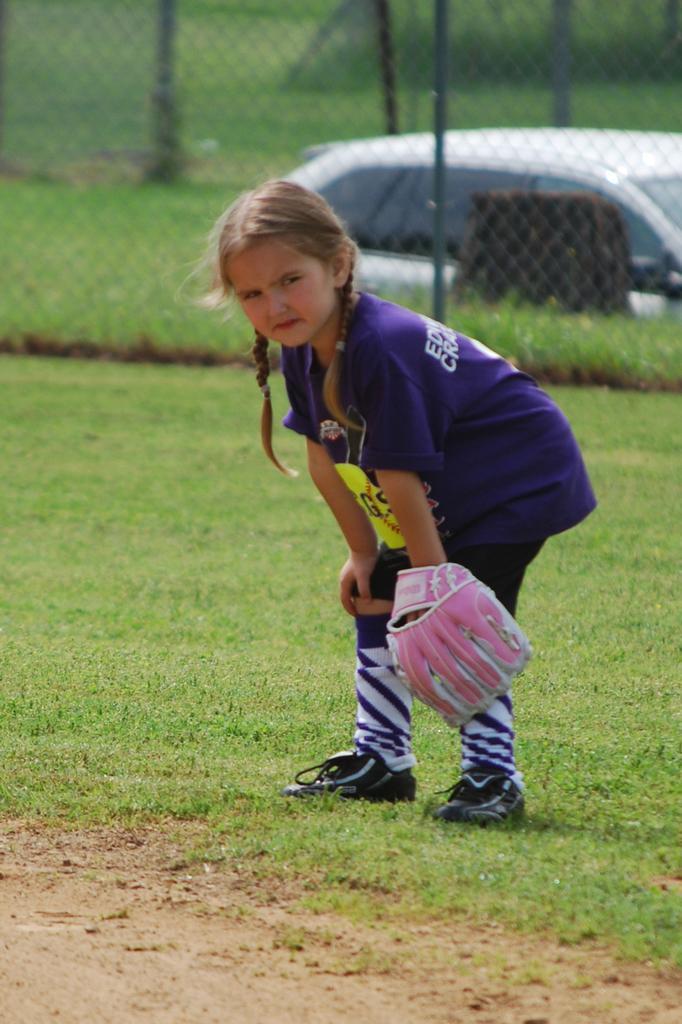How would you summarize this image in a sentence or two? In this image I can see a girl in the front. In the background I can see the iron fence, a white colour car and an open grass ground. I can also see few poles and I can see this image is little bit blurry. 